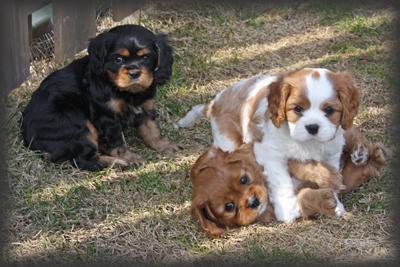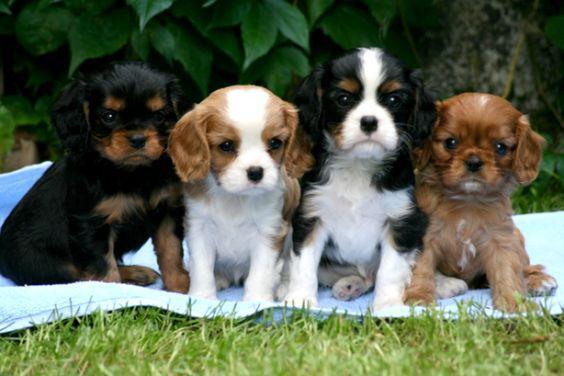The first image is the image on the left, the second image is the image on the right. Given the left and right images, does the statement "An image shows one tan-and-white spaniel reclining directly on green grass." hold true? Answer yes or no. No. 